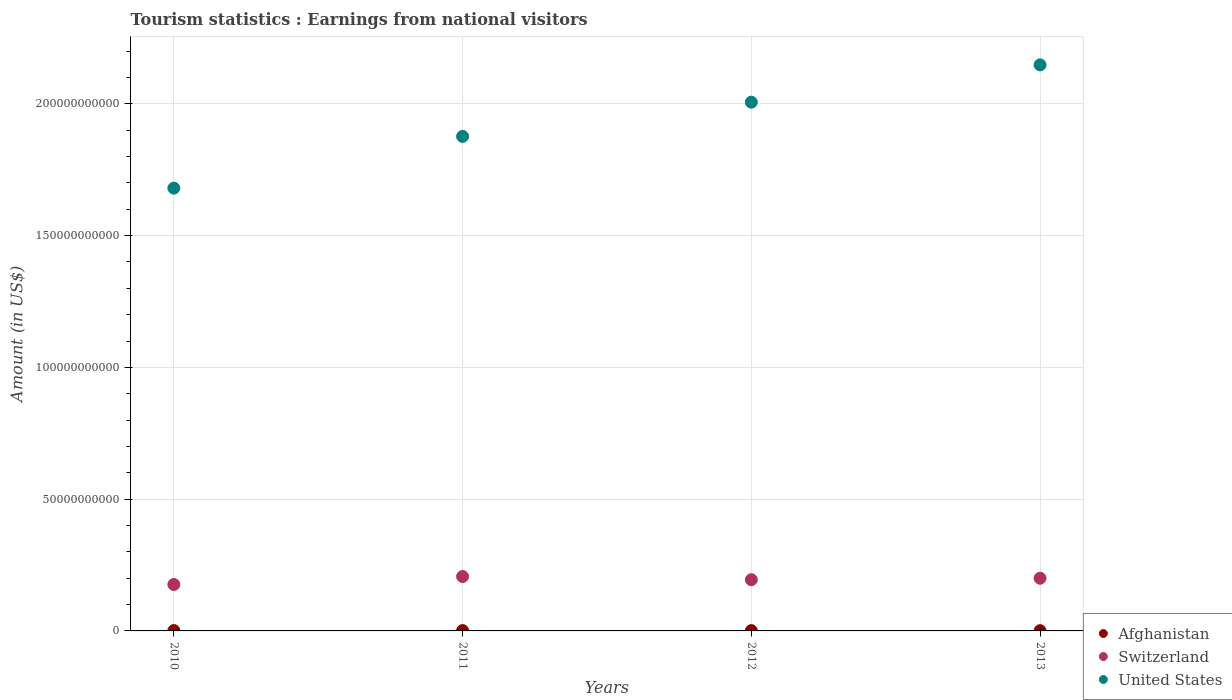Is the number of dotlines equal to the number of legend labels?
Give a very brief answer. Yes. What is the earnings from national visitors in Switzerland in 2013?
Your response must be concise. 2.00e+1. Across all years, what is the maximum earnings from national visitors in Switzerland?
Give a very brief answer. 2.06e+1. Across all years, what is the minimum earnings from national visitors in Afghanistan?
Your answer should be compact. 8.90e+07. In which year was the earnings from national visitors in United States maximum?
Make the answer very short. 2013. What is the total earnings from national visitors in Switzerland in the graph?
Your answer should be compact. 7.77e+1. What is the difference between the earnings from national visitors in Afghanistan in 2011 and that in 2012?
Your answer should be very brief. 2.10e+07. What is the difference between the earnings from national visitors in Switzerland in 2012 and the earnings from national visitors in United States in 2010?
Your response must be concise. -1.49e+11. What is the average earnings from national visitors in United States per year?
Offer a terse response. 1.93e+11. In the year 2012, what is the difference between the earnings from national visitors in Switzerland and earnings from national visitors in Afghanistan?
Your answer should be compact. 1.93e+1. In how many years, is the earnings from national visitors in Afghanistan greater than 30000000000 US$?
Give a very brief answer. 0. What is the ratio of the earnings from national visitors in Afghanistan in 2010 to that in 2011?
Your answer should be compact. 1.01. What is the difference between the highest and the second highest earnings from national visitors in United States?
Give a very brief answer. 1.42e+1. What is the difference between the highest and the lowest earnings from national visitors in United States?
Make the answer very short. 4.68e+1. In how many years, is the earnings from national visitors in Switzerland greater than the average earnings from national visitors in Switzerland taken over all years?
Provide a short and direct response. 3. Is the earnings from national visitors in Switzerland strictly greater than the earnings from national visitors in United States over the years?
Your response must be concise. No. How many dotlines are there?
Your answer should be very brief. 3. What is the difference between two consecutive major ticks on the Y-axis?
Provide a short and direct response. 5.00e+1. How are the legend labels stacked?
Ensure brevity in your answer.  Vertical. What is the title of the graph?
Ensure brevity in your answer.  Tourism statistics : Earnings from national visitors. What is the Amount (in US$) of Afghanistan in 2010?
Your answer should be very brief. 1.38e+08. What is the Amount (in US$) in Switzerland in 2010?
Your response must be concise. 1.76e+1. What is the Amount (in US$) of United States in 2010?
Provide a short and direct response. 1.68e+11. What is the Amount (in US$) in Afghanistan in 2011?
Give a very brief answer. 1.37e+08. What is the Amount (in US$) in Switzerland in 2011?
Your response must be concise. 2.06e+1. What is the Amount (in US$) of United States in 2011?
Keep it short and to the point. 1.88e+11. What is the Amount (in US$) in Afghanistan in 2012?
Provide a short and direct response. 1.16e+08. What is the Amount (in US$) in Switzerland in 2012?
Give a very brief answer. 1.94e+1. What is the Amount (in US$) of United States in 2012?
Give a very brief answer. 2.01e+11. What is the Amount (in US$) in Afghanistan in 2013?
Offer a terse response. 8.90e+07. What is the Amount (in US$) of Switzerland in 2013?
Give a very brief answer. 2.00e+1. What is the Amount (in US$) in United States in 2013?
Provide a short and direct response. 2.15e+11. Across all years, what is the maximum Amount (in US$) of Afghanistan?
Keep it short and to the point. 1.38e+08. Across all years, what is the maximum Amount (in US$) in Switzerland?
Offer a very short reply. 2.06e+1. Across all years, what is the maximum Amount (in US$) in United States?
Offer a very short reply. 2.15e+11. Across all years, what is the minimum Amount (in US$) of Afghanistan?
Ensure brevity in your answer.  8.90e+07. Across all years, what is the minimum Amount (in US$) of Switzerland?
Your answer should be compact. 1.76e+1. Across all years, what is the minimum Amount (in US$) in United States?
Offer a very short reply. 1.68e+11. What is the total Amount (in US$) of Afghanistan in the graph?
Ensure brevity in your answer.  4.80e+08. What is the total Amount (in US$) in Switzerland in the graph?
Your answer should be compact. 7.77e+1. What is the total Amount (in US$) of United States in the graph?
Provide a short and direct response. 7.71e+11. What is the difference between the Amount (in US$) in Switzerland in 2010 and that in 2011?
Offer a terse response. -3.03e+09. What is the difference between the Amount (in US$) in United States in 2010 and that in 2011?
Your answer should be very brief. -1.96e+1. What is the difference between the Amount (in US$) of Afghanistan in 2010 and that in 2012?
Ensure brevity in your answer.  2.20e+07. What is the difference between the Amount (in US$) in Switzerland in 2010 and that in 2012?
Offer a very short reply. -1.82e+09. What is the difference between the Amount (in US$) in United States in 2010 and that in 2012?
Your response must be concise. -3.26e+1. What is the difference between the Amount (in US$) of Afghanistan in 2010 and that in 2013?
Your answer should be very brief. 4.90e+07. What is the difference between the Amount (in US$) in Switzerland in 2010 and that in 2013?
Your answer should be compact. -2.38e+09. What is the difference between the Amount (in US$) in United States in 2010 and that in 2013?
Offer a terse response. -4.68e+1. What is the difference between the Amount (in US$) in Afghanistan in 2011 and that in 2012?
Make the answer very short. 2.10e+07. What is the difference between the Amount (in US$) of Switzerland in 2011 and that in 2012?
Ensure brevity in your answer.  1.20e+09. What is the difference between the Amount (in US$) in United States in 2011 and that in 2012?
Make the answer very short. -1.30e+1. What is the difference between the Amount (in US$) in Afghanistan in 2011 and that in 2013?
Offer a very short reply. 4.80e+07. What is the difference between the Amount (in US$) in Switzerland in 2011 and that in 2013?
Ensure brevity in your answer.  6.48e+08. What is the difference between the Amount (in US$) in United States in 2011 and that in 2013?
Ensure brevity in your answer.  -2.71e+1. What is the difference between the Amount (in US$) of Afghanistan in 2012 and that in 2013?
Ensure brevity in your answer.  2.70e+07. What is the difference between the Amount (in US$) in Switzerland in 2012 and that in 2013?
Your answer should be compact. -5.53e+08. What is the difference between the Amount (in US$) of United States in 2012 and that in 2013?
Offer a terse response. -1.42e+1. What is the difference between the Amount (in US$) of Afghanistan in 2010 and the Amount (in US$) of Switzerland in 2011?
Offer a very short reply. -2.05e+1. What is the difference between the Amount (in US$) in Afghanistan in 2010 and the Amount (in US$) in United States in 2011?
Give a very brief answer. -1.87e+11. What is the difference between the Amount (in US$) in Switzerland in 2010 and the Amount (in US$) in United States in 2011?
Keep it short and to the point. -1.70e+11. What is the difference between the Amount (in US$) in Afghanistan in 2010 and the Amount (in US$) in Switzerland in 2012?
Make the answer very short. -1.93e+1. What is the difference between the Amount (in US$) in Afghanistan in 2010 and the Amount (in US$) in United States in 2012?
Ensure brevity in your answer.  -2.00e+11. What is the difference between the Amount (in US$) of Switzerland in 2010 and the Amount (in US$) of United States in 2012?
Keep it short and to the point. -1.83e+11. What is the difference between the Amount (in US$) in Afghanistan in 2010 and the Amount (in US$) in Switzerland in 2013?
Offer a very short reply. -1.99e+1. What is the difference between the Amount (in US$) of Afghanistan in 2010 and the Amount (in US$) of United States in 2013?
Your response must be concise. -2.15e+11. What is the difference between the Amount (in US$) in Switzerland in 2010 and the Amount (in US$) in United States in 2013?
Give a very brief answer. -1.97e+11. What is the difference between the Amount (in US$) of Afghanistan in 2011 and the Amount (in US$) of Switzerland in 2012?
Provide a succinct answer. -1.93e+1. What is the difference between the Amount (in US$) in Afghanistan in 2011 and the Amount (in US$) in United States in 2012?
Your answer should be very brief. -2.00e+11. What is the difference between the Amount (in US$) of Switzerland in 2011 and the Amount (in US$) of United States in 2012?
Offer a very short reply. -1.80e+11. What is the difference between the Amount (in US$) of Afghanistan in 2011 and the Amount (in US$) of Switzerland in 2013?
Provide a succinct answer. -1.99e+1. What is the difference between the Amount (in US$) of Afghanistan in 2011 and the Amount (in US$) of United States in 2013?
Keep it short and to the point. -2.15e+11. What is the difference between the Amount (in US$) in Switzerland in 2011 and the Amount (in US$) in United States in 2013?
Your answer should be compact. -1.94e+11. What is the difference between the Amount (in US$) of Afghanistan in 2012 and the Amount (in US$) of Switzerland in 2013?
Ensure brevity in your answer.  -1.99e+1. What is the difference between the Amount (in US$) in Afghanistan in 2012 and the Amount (in US$) in United States in 2013?
Make the answer very short. -2.15e+11. What is the difference between the Amount (in US$) of Switzerland in 2012 and the Amount (in US$) of United States in 2013?
Make the answer very short. -1.95e+11. What is the average Amount (in US$) in Afghanistan per year?
Your response must be concise. 1.20e+08. What is the average Amount (in US$) of Switzerland per year?
Provide a short and direct response. 1.94e+1. What is the average Amount (in US$) of United States per year?
Offer a very short reply. 1.93e+11. In the year 2010, what is the difference between the Amount (in US$) of Afghanistan and Amount (in US$) of Switzerland?
Provide a succinct answer. -1.75e+1. In the year 2010, what is the difference between the Amount (in US$) of Afghanistan and Amount (in US$) of United States?
Keep it short and to the point. -1.68e+11. In the year 2010, what is the difference between the Amount (in US$) in Switzerland and Amount (in US$) in United States?
Offer a terse response. -1.50e+11. In the year 2011, what is the difference between the Amount (in US$) in Afghanistan and Amount (in US$) in Switzerland?
Provide a short and direct response. -2.05e+1. In the year 2011, what is the difference between the Amount (in US$) of Afghanistan and Amount (in US$) of United States?
Offer a terse response. -1.87e+11. In the year 2011, what is the difference between the Amount (in US$) in Switzerland and Amount (in US$) in United States?
Ensure brevity in your answer.  -1.67e+11. In the year 2012, what is the difference between the Amount (in US$) in Afghanistan and Amount (in US$) in Switzerland?
Offer a very short reply. -1.93e+1. In the year 2012, what is the difference between the Amount (in US$) in Afghanistan and Amount (in US$) in United States?
Offer a very short reply. -2.00e+11. In the year 2012, what is the difference between the Amount (in US$) of Switzerland and Amount (in US$) of United States?
Offer a very short reply. -1.81e+11. In the year 2013, what is the difference between the Amount (in US$) in Afghanistan and Amount (in US$) in Switzerland?
Offer a terse response. -1.99e+1. In the year 2013, what is the difference between the Amount (in US$) in Afghanistan and Amount (in US$) in United States?
Offer a terse response. -2.15e+11. In the year 2013, what is the difference between the Amount (in US$) in Switzerland and Amount (in US$) in United States?
Provide a succinct answer. -1.95e+11. What is the ratio of the Amount (in US$) of Afghanistan in 2010 to that in 2011?
Offer a terse response. 1.01. What is the ratio of the Amount (in US$) in Switzerland in 2010 to that in 2011?
Keep it short and to the point. 0.85. What is the ratio of the Amount (in US$) of United States in 2010 to that in 2011?
Provide a short and direct response. 0.9. What is the ratio of the Amount (in US$) of Afghanistan in 2010 to that in 2012?
Your answer should be very brief. 1.19. What is the ratio of the Amount (in US$) of Switzerland in 2010 to that in 2012?
Keep it short and to the point. 0.91. What is the ratio of the Amount (in US$) of United States in 2010 to that in 2012?
Your answer should be compact. 0.84. What is the ratio of the Amount (in US$) in Afghanistan in 2010 to that in 2013?
Your response must be concise. 1.55. What is the ratio of the Amount (in US$) in Switzerland in 2010 to that in 2013?
Provide a succinct answer. 0.88. What is the ratio of the Amount (in US$) in United States in 2010 to that in 2013?
Offer a very short reply. 0.78. What is the ratio of the Amount (in US$) of Afghanistan in 2011 to that in 2012?
Ensure brevity in your answer.  1.18. What is the ratio of the Amount (in US$) of Switzerland in 2011 to that in 2012?
Keep it short and to the point. 1.06. What is the ratio of the Amount (in US$) in United States in 2011 to that in 2012?
Offer a very short reply. 0.94. What is the ratio of the Amount (in US$) in Afghanistan in 2011 to that in 2013?
Your answer should be very brief. 1.54. What is the ratio of the Amount (in US$) of Switzerland in 2011 to that in 2013?
Offer a very short reply. 1.03. What is the ratio of the Amount (in US$) in United States in 2011 to that in 2013?
Offer a very short reply. 0.87. What is the ratio of the Amount (in US$) of Afghanistan in 2012 to that in 2013?
Your answer should be very brief. 1.3. What is the ratio of the Amount (in US$) in Switzerland in 2012 to that in 2013?
Provide a short and direct response. 0.97. What is the ratio of the Amount (in US$) in United States in 2012 to that in 2013?
Offer a terse response. 0.93. What is the difference between the highest and the second highest Amount (in US$) of Switzerland?
Keep it short and to the point. 6.48e+08. What is the difference between the highest and the second highest Amount (in US$) in United States?
Ensure brevity in your answer.  1.42e+1. What is the difference between the highest and the lowest Amount (in US$) in Afghanistan?
Offer a very short reply. 4.90e+07. What is the difference between the highest and the lowest Amount (in US$) of Switzerland?
Offer a terse response. 3.03e+09. What is the difference between the highest and the lowest Amount (in US$) of United States?
Provide a succinct answer. 4.68e+1. 